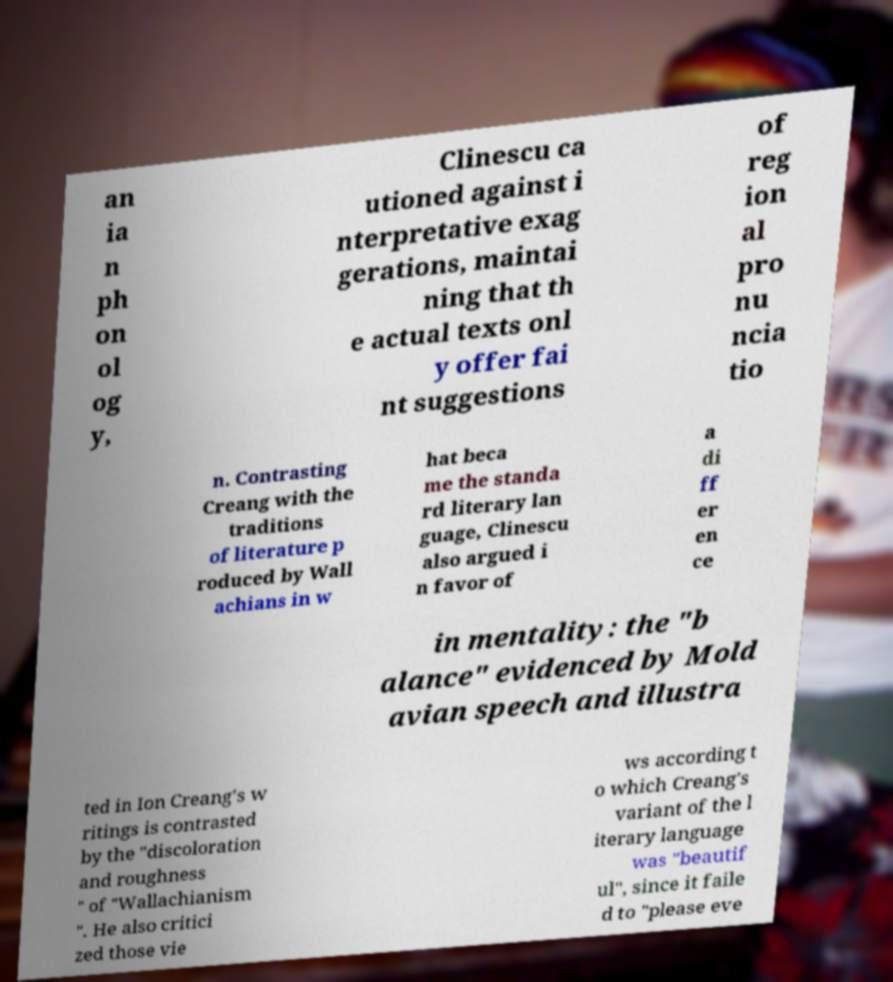There's text embedded in this image that I need extracted. Can you transcribe it verbatim? an ia n ph on ol og y, Clinescu ca utioned against i nterpretative exag gerations, maintai ning that th e actual texts onl y offer fai nt suggestions of reg ion al pro nu ncia tio n. Contrasting Creang with the traditions of literature p roduced by Wall achians in w hat beca me the standa rd literary lan guage, Clinescu also argued i n favor of a di ff er en ce in mentality: the "b alance" evidenced by Mold avian speech and illustra ted in Ion Creang's w ritings is contrasted by the "discoloration and roughness " of "Wallachianism ". He also critici zed those vie ws according t o which Creang's variant of the l iterary language was "beautif ul", since it faile d to "please eve 